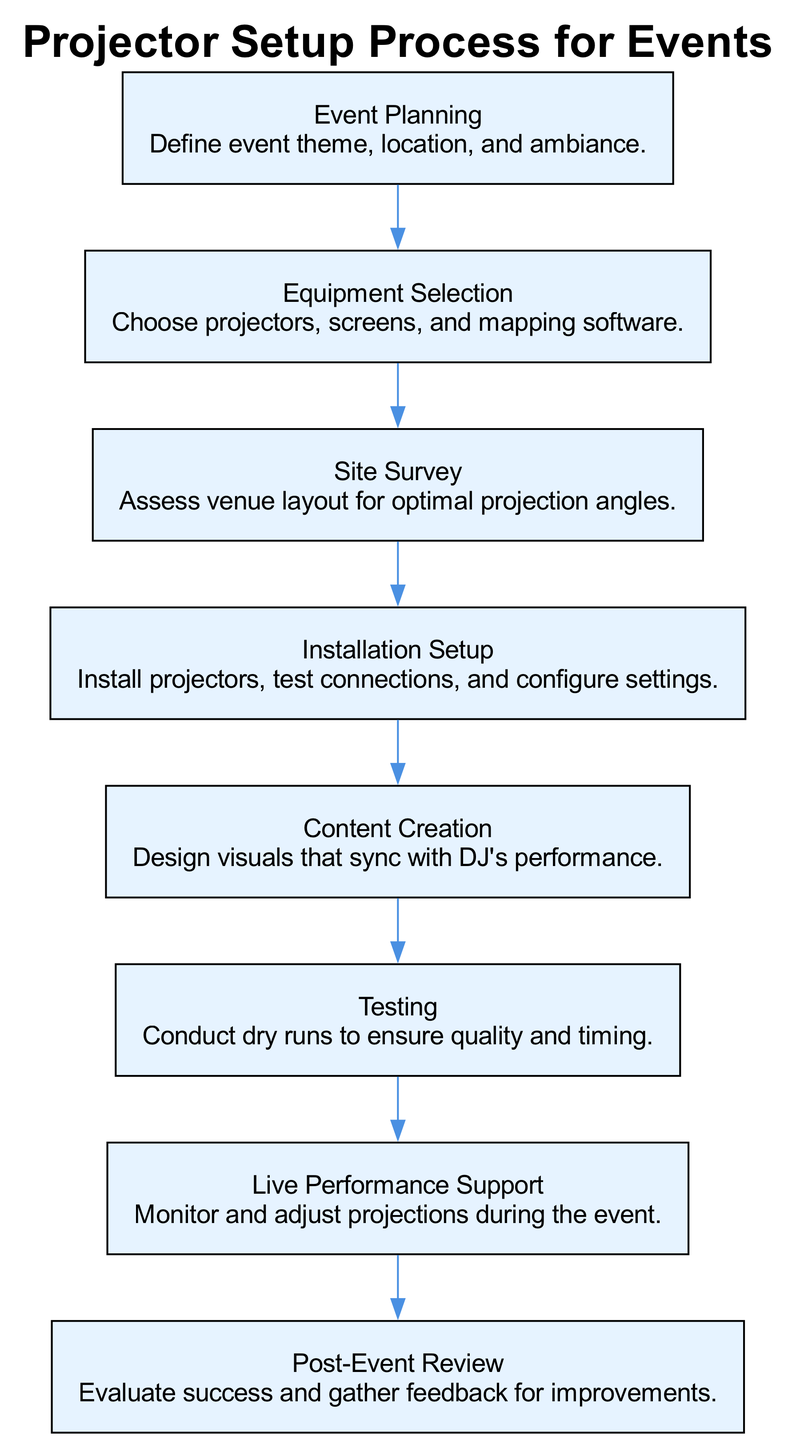What is the first step in the projector setup process? The first step in the flow chart is "Event Planning," which establishes the theme, location, and ambiance for the event.
Answer: Event Planning How many total steps are in the process? By counting each step listed in the process, there are a total of eight steps in the diagram.
Answer: 8 What follows "Equipment Selection" in the process? "Site Survey" directly follows "Equipment Selection," indicating that after selecting equipment, an assessment of the venue is performed.
Answer: Site Survey Which step involves testing the quality and timing? The "Testing" step specifically refers to conducting dry runs to ensure the quality of the projections and their timing with the DJ’s performance.
Answer: Testing What is the last step in the projector setup process? The last step shown in the flow chart is "Post-Event Review," which evaluates the success of the event and gathers feedback for improvements.
Answer: Post-Event Review Which steps are directly connected to "Live Performance Support"? "Testing" directly leads to "Live Performance Support," indicating that testing is crucial for ensuring support during the actual performance.
Answer: Testing In which step are visuals designed? "Content Creation" is the step where visuals are designed to sync with the DJ's performance, indicating the creative aspect of the setup.
Answer: Content Creation What is the function of the "Installation Setup" step? The "Installation Setup" step involves the installation of projectors, testing connections, and configuring settings, ensuring everything is ready prior to the event.
Answer: Install projectors, test connections, configure settings 